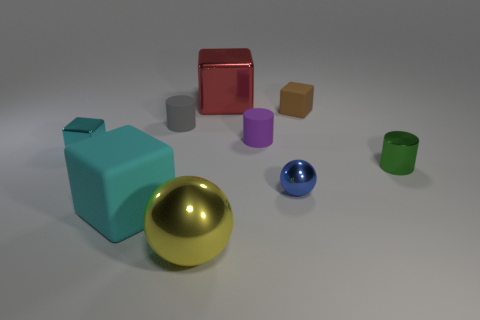Subtract all large rubber blocks. How many blocks are left? 3 Subtract all brown spheres. How many cyan blocks are left? 2 Subtract all brown cubes. How many cubes are left? 3 Subtract 1 cubes. How many cubes are left? 3 Subtract all blue blocks. Subtract all green spheres. How many blocks are left? 4 Subtract all spheres. How many objects are left? 7 Add 9 yellow balls. How many yellow balls exist? 10 Subtract 0 yellow cylinders. How many objects are left? 9 Subtract all purple rubber cylinders. Subtract all tiny purple objects. How many objects are left? 7 Add 5 metallic blocks. How many metallic blocks are left? 7 